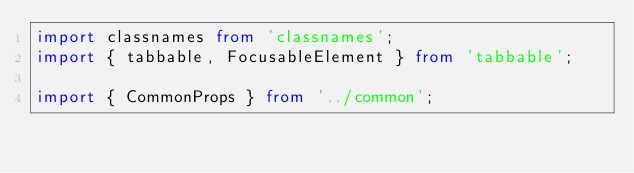<code> <loc_0><loc_0><loc_500><loc_500><_TypeScript_>import classnames from 'classnames';
import { tabbable, FocusableElement } from 'tabbable';

import { CommonProps } from '../common';</code> 